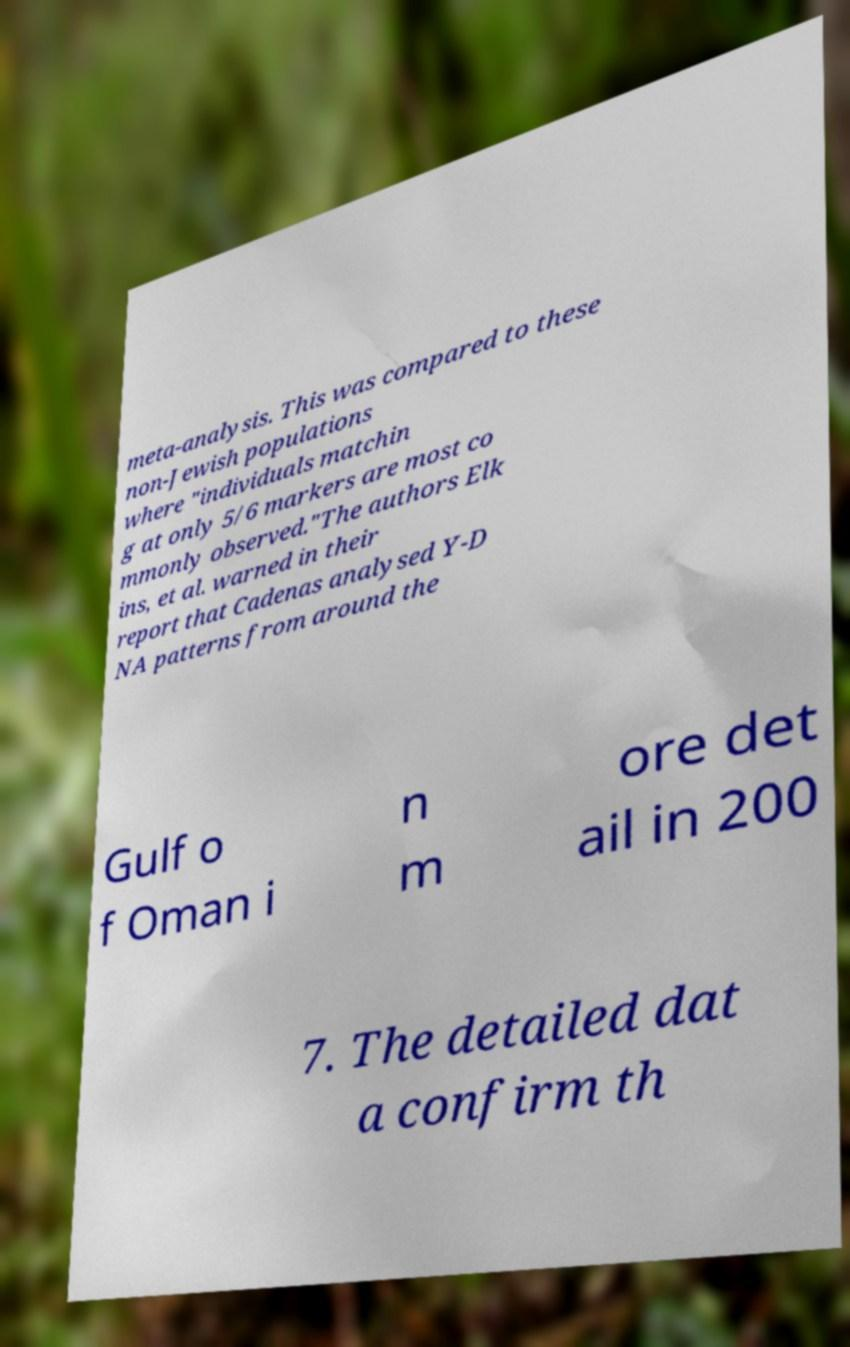Can you accurately transcribe the text from the provided image for me? meta-analysis. This was compared to these non-Jewish populations where "individuals matchin g at only 5/6 markers are most co mmonly observed."The authors Elk ins, et al. warned in their report that Cadenas analysed Y-D NA patterns from around the Gulf o f Oman i n m ore det ail in 200 7. The detailed dat a confirm th 